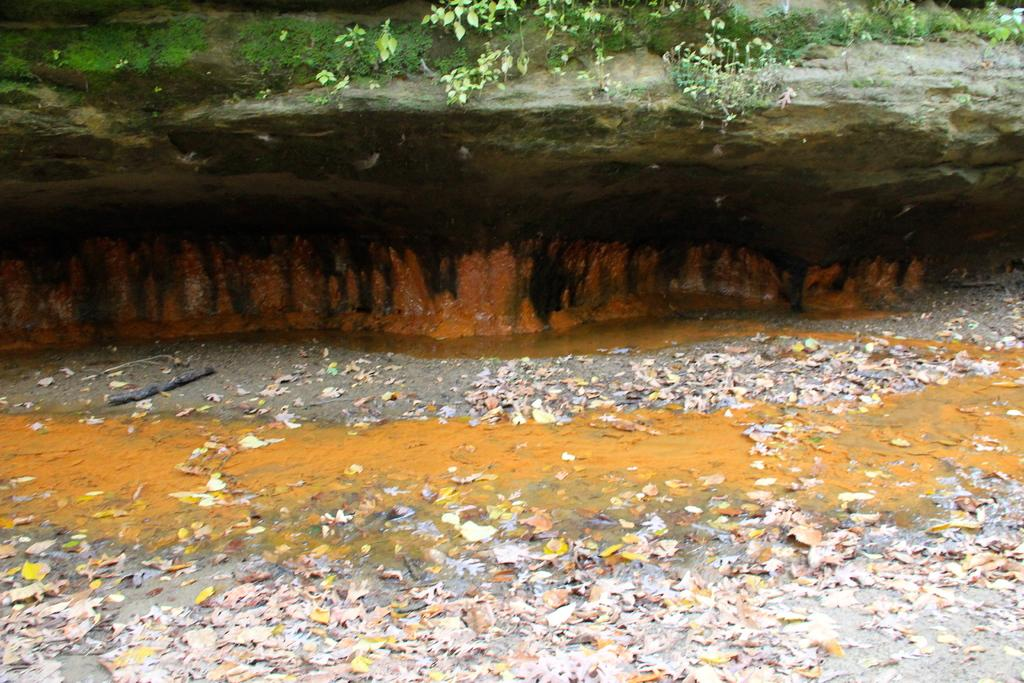What type of vegetation can be seen on the ground in the image? There are leaves on the ground in the image. What other types of vegetation are present in the image? There are plants and grass in the image. How many beds can be seen in the image? There are no beds present in the image. What type of writing instrument is used by the plants in the image? Plants do not use writing instruments, so this question cannot be answered. 